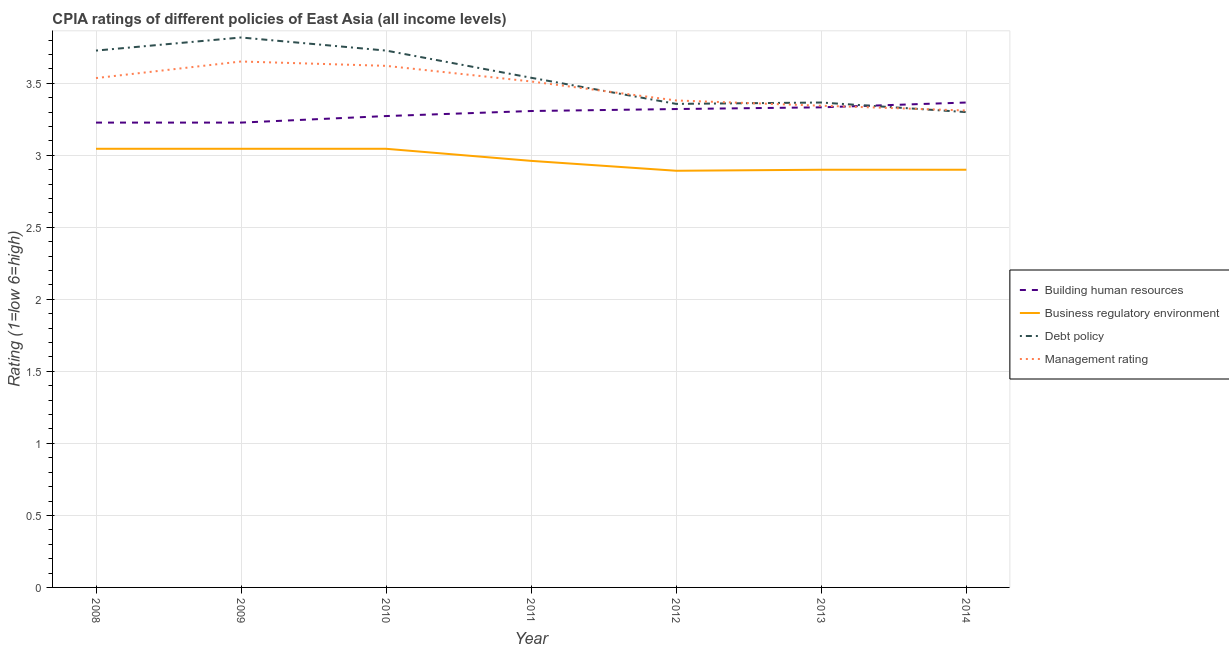What is the cpia rating of debt policy in 2011?
Provide a succinct answer. 3.54. Across all years, what is the maximum cpia rating of building human resources?
Provide a succinct answer. 3.37. What is the total cpia rating of building human resources in the graph?
Offer a terse response. 23.06. What is the difference between the cpia rating of debt policy in 2009 and that in 2011?
Offer a terse response. 0.28. What is the difference between the cpia rating of management in 2014 and the cpia rating of business regulatory environment in 2009?
Keep it short and to the point. 0.27. What is the average cpia rating of debt policy per year?
Provide a short and direct response. 3.55. In the year 2009, what is the difference between the cpia rating of management and cpia rating of debt policy?
Make the answer very short. -0.17. In how many years, is the cpia rating of management greater than 0.6?
Give a very brief answer. 7. What is the ratio of the cpia rating of business regulatory environment in 2010 to that in 2011?
Your answer should be compact. 1.03. Is the cpia rating of management in 2008 less than that in 2013?
Your answer should be compact. No. What is the difference between the highest and the second highest cpia rating of building human resources?
Your response must be concise. 0.03. What is the difference between the highest and the lowest cpia rating of building human resources?
Your response must be concise. 0.14. Is it the case that in every year, the sum of the cpia rating of management and cpia rating of business regulatory environment is greater than the sum of cpia rating of building human resources and cpia rating of debt policy?
Provide a short and direct response. No. Is it the case that in every year, the sum of the cpia rating of building human resources and cpia rating of business regulatory environment is greater than the cpia rating of debt policy?
Offer a very short reply. Yes. Does the graph contain grids?
Provide a succinct answer. Yes. Where does the legend appear in the graph?
Your answer should be compact. Center right. What is the title of the graph?
Give a very brief answer. CPIA ratings of different policies of East Asia (all income levels). Does "First 20% of population" appear as one of the legend labels in the graph?
Offer a terse response. No. What is the label or title of the X-axis?
Your response must be concise. Year. What is the label or title of the Y-axis?
Provide a succinct answer. Rating (1=low 6=high). What is the Rating (1=low 6=high) of Building human resources in 2008?
Make the answer very short. 3.23. What is the Rating (1=low 6=high) in Business regulatory environment in 2008?
Your answer should be very brief. 3.05. What is the Rating (1=low 6=high) of Debt policy in 2008?
Ensure brevity in your answer.  3.73. What is the Rating (1=low 6=high) in Management rating in 2008?
Your answer should be compact. 3.54. What is the Rating (1=low 6=high) of Building human resources in 2009?
Your answer should be very brief. 3.23. What is the Rating (1=low 6=high) of Business regulatory environment in 2009?
Offer a very short reply. 3.05. What is the Rating (1=low 6=high) of Debt policy in 2009?
Your answer should be very brief. 3.82. What is the Rating (1=low 6=high) of Management rating in 2009?
Give a very brief answer. 3.65. What is the Rating (1=low 6=high) in Building human resources in 2010?
Make the answer very short. 3.27. What is the Rating (1=low 6=high) in Business regulatory environment in 2010?
Give a very brief answer. 3.05. What is the Rating (1=low 6=high) of Debt policy in 2010?
Offer a terse response. 3.73. What is the Rating (1=low 6=high) in Management rating in 2010?
Provide a short and direct response. 3.62. What is the Rating (1=low 6=high) in Building human resources in 2011?
Offer a terse response. 3.31. What is the Rating (1=low 6=high) in Business regulatory environment in 2011?
Offer a very short reply. 2.96. What is the Rating (1=low 6=high) of Debt policy in 2011?
Offer a terse response. 3.54. What is the Rating (1=low 6=high) in Management rating in 2011?
Offer a terse response. 3.51. What is the Rating (1=low 6=high) of Building human resources in 2012?
Provide a succinct answer. 3.32. What is the Rating (1=low 6=high) of Business regulatory environment in 2012?
Keep it short and to the point. 2.89. What is the Rating (1=low 6=high) in Debt policy in 2012?
Offer a very short reply. 3.36. What is the Rating (1=low 6=high) in Management rating in 2012?
Your answer should be compact. 3.38. What is the Rating (1=low 6=high) in Building human resources in 2013?
Provide a short and direct response. 3.33. What is the Rating (1=low 6=high) in Business regulatory environment in 2013?
Provide a short and direct response. 2.9. What is the Rating (1=low 6=high) of Debt policy in 2013?
Provide a succinct answer. 3.37. What is the Rating (1=low 6=high) in Management rating in 2013?
Your response must be concise. 3.34. What is the Rating (1=low 6=high) of Building human resources in 2014?
Give a very brief answer. 3.37. What is the Rating (1=low 6=high) of Business regulatory environment in 2014?
Make the answer very short. 2.9. What is the Rating (1=low 6=high) of Management rating in 2014?
Ensure brevity in your answer.  3.31. Across all years, what is the maximum Rating (1=low 6=high) of Building human resources?
Your response must be concise. 3.37. Across all years, what is the maximum Rating (1=low 6=high) of Business regulatory environment?
Your answer should be very brief. 3.05. Across all years, what is the maximum Rating (1=low 6=high) in Debt policy?
Your answer should be compact. 3.82. Across all years, what is the maximum Rating (1=low 6=high) of Management rating?
Your answer should be compact. 3.65. Across all years, what is the minimum Rating (1=low 6=high) in Building human resources?
Your response must be concise. 3.23. Across all years, what is the minimum Rating (1=low 6=high) in Business regulatory environment?
Your response must be concise. 2.89. Across all years, what is the minimum Rating (1=low 6=high) of Debt policy?
Provide a short and direct response. 3.3. Across all years, what is the minimum Rating (1=low 6=high) in Management rating?
Provide a short and direct response. 3.31. What is the total Rating (1=low 6=high) of Building human resources in the graph?
Your response must be concise. 23.06. What is the total Rating (1=low 6=high) in Business regulatory environment in the graph?
Provide a succinct answer. 20.79. What is the total Rating (1=low 6=high) of Debt policy in the graph?
Provide a short and direct response. 24.84. What is the total Rating (1=low 6=high) in Management rating in the graph?
Keep it short and to the point. 24.36. What is the difference between the Rating (1=low 6=high) of Business regulatory environment in 2008 and that in 2009?
Your answer should be very brief. 0. What is the difference between the Rating (1=low 6=high) in Debt policy in 2008 and that in 2009?
Provide a succinct answer. -0.09. What is the difference between the Rating (1=low 6=high) in Management rating in 2008 and that in 2009?
Ensure brevity in your answer.  -0.12. What is the difference between the Rating (1=low 6=high) in Building human resources in 2008 and that in 2010?
Give a very brief answer. -0.05. What is the difference between the Rating (1=low 6=high) of Debt policy in 2008 and that in 2010?
Make the answer very short. 0. What is the difference between the Rating (1=low 6=high) in Management rating in 2008 and that in 2010?
Offer a very short reply. -0.08. What is the difference between the Rating (1=low 6=high) in Building human resources in 2008 and that in 2011?
Give a very brief answer. -0.08. What is the difference between the Rating (1=low 6=high) in Business regulatory environment in 2008 and that in 2011?
Offer a very short reply. 0.08. What is the difference between the Rating (1=low 6=high) in Debt policy in 2008 and that in 2011?
Give a very brief answer. 0.19. What is the difference between the Rating (1=low 6=high) of Management rating in 2008 and that in 2011?
Offer a very short reply. 0.02. What is the difference between the Rating (1=low 6=high) of Building human resources in 2008 and that in 2012?
Your response must be concise. -0.09. What is the difference between the Rating (1=low 6=high) of Business regulatory environment in 2008 and that in 2012?
Offer a very short reply. 0.15. What is the difference between the Rating (1=low 6=high) in Debt policy in 2008 and that in 2012?
Provide a short and direct response. 0.37. What is the difference between the Rating (1=low 6=high) in Management rating in 2008 and that in 2012?
Ensure brevity in your answer.  0.16. What is the difference between the Rating (1=low 6=high) of Building human resources in 2008 and that in 2013?
Your response must be concise. -0.11. What is the difference between the Rating (1=low 6=high) of Business regulatory environment in 2008 and that in 2013?
Ensure brevity in your answer.  0.15. What is the difference between the Rating (1=low 6=high) in Debt policy in 2008 and that in 2013?
Your response must be concise. 0.36. What is the difference between the Rating (1=low 6=high) of Management rating in 2008 and that in 2013?
Ensure brevity in your answer.  0.19. What is the difference between the Rating (1=low 6=high) in Building human resources in 2008 and that in 2014?
Ensure brevity in your answer.  -0.14. What is the difference between the Rating (1=low 6=high) of Business regulatory environment in 2008 and that in 2014?
Your answer should be very brief. 0.15. What is the difference between the Rating (1=low 6=high) of Debt policy in 2008 and that in 2014?
Make the answer very short. 0.43. What is the difference between the Rating (1=low 6=high) in Management rating in 2008 and that in 2014?
Your answer should be compact. 0.23. What is the difference between the Rating (1=low 6=high) of Building human resources in 2009 and that in 2010?
Your response must be concise. -0.05. What is the difference between the Rating (1=low 6=high) in Debt policy in 2009 and that in 2010?
Provide a succinct answer. 0.09. What is the difference between the Rating (1=low 6=high) of Management rating in 2009 and that in 2010?
Offer a terse response. 0.03. What is the difference between the Rating (1=low 6=high) in Building human resources in 2009 and that in 2011?
Keep it short and to the point. -0.08. What is the difference between the Rating (1=low 6=high) in Business regulatory environment in 2009 and that in 2011?
Offer a very short reply. 0.08. What is the difference between the Rating (1=low 6=high) in Debt policy in 2009 and that in 2011?
Make the answer very short. 0.28. What is the difference between the Rating (1=low 6=high) in Management rating in 2009 and that in 2011?
Provide a short and direct response. 0.14. What is the difference between the Rating (1=low 6=high) in Building human resources in 2009 and that in 2012?
Provide a succinct answer. -0.09. What is the difference between the Rating (1=low 6=high) of Business regulatory environment in 2009 and that in 2012?
Offer a terse response. 0.15. What is the difference between the Rating (1=low 6=high) in Debt policy in 2009 and that in 2012?
Offer a very short reply. 0.46. What is the difference between the Rating (1=low 6=high) in Management rating in 2009 and that in 2012?
Offer a terse response. 0.27. What is the difference between the Rating (1=low 6=high) of Building human resources in 2009 and that in 2013?
Make the answer very short. -0.11. What is the difference between the Rating (1=low 6=high) of Business regulatory environment in 2009 and that in 2013?
Ensure brevity in your answer.  0.15. What is the difference between the Rating (1=low 6=high) of Debt policy in 2009 and that in 2013?
Provide a short and direct response. 0.45. What is the difference between the Rating (1=low 6=high) of Management rating in 2009 and that in 2013?
Provide a succinct answer. 0.31. What is the difference between the Rating (1=low 6=high) in Building human resources in 2009 and that in 2014?
Offer a very short reply. -0.14. What is the difference between the Rating (1=low 6=high) of Business regulatory environment in 2009 and that in 2014?
Make the answer very short. 0.15. What is the difference between the Rating (1=low 6=high) of Debt policy in 2009 and that in 2014?
Your response must be concise. 0.52. What is the difference between the Rating (1=low 6=high) in Management rating in 2009 and that in 2014?
Give a very brief answer. 0.34. What is the difference between the Rating (1=low 6=high) in Building human resources in 2010 and that in 2011?
Keep it short and to the point. -0.04. What is the difference between the Rating (1=low 6=high) in Business regulatory environment in 2010 and that in 2011?
Your answer should be very brief. 0.08. What is the difference between the Rating (1=low 6=high) in Debt policy in 2010 and that in 2011?
Keep it short and to the point. 0.19. What is the difference between the Rating (1=low 6=high) in Management rating in 2010 and that in 2011?
Offer a very short reply. 0.11. What is the difference between the Rating (1=low 6=high) of Building human resources in 2010 and that in 2012?
Ensure brevity in your answer.  -0.05. What is the difference between the Rating (1=low 6=high) of Business regulatory environment in 2010 and that in 2012?
Provide a succinct answer. 0.15. What is the difference between the Rating (1=low 6=high) of Debt policy in 2010 and that in 2012?
Ensure brevity in your answer.  0.37. What is the difference between the Rating (1=low 6=high) in Management rating in 2010 and that in 2012?
Make the answer very short. 0.24. What is the difference between the Rating (1=low 6=high) in Building human resources in 2010 and that in 2013?
Make the answer very short. -0.06. What is the difference between the Rating (1=low 6=high) of Business regulatory environment in 2010 and that in 2013?
Your answer should be compact. 0.15. What is the difference between the Rating (1=low 6=high) of Debt policy in 2010 and that in 2013?
Provide a short and direct response. 0.36. What is the difference between the Rating (1=low 6=high) in Management rating in 2010 and that in 2013?
Provide a short and direct response. 0.28. What is the difference between the Rating (1=low 6=high) in Building human resources in 2010 and that in 2014?
Give a very brief answer. -0.09. What is the difference between the Rating (1=low 6=high) of Business regulatory environment in 2010 and that in 2014?
Provide a succinct answer. 0.15. What is the difference between the Rating (1=low 6=high) in Debt policy in 2010 and that in 2014?
Offer a very short reply. 0.43. What is the difference between the Rating (1=low 6=high) of Management rating in 2010 and that in 2014?
Your answer should be compact. 0.31. What is the difference between the Rating (1=low 6=high) of Building human resources in 2011 and that in 2012?
Keep it short and to the point. -0.01. What is the difference between the Rating (1=low 6=high) of Business regulatory environment in 2011 and that in 2012?
Give a very brief answer. 0.07. What is the difference between the Rating (1=low 6=high) in Debt policy in 2011 and that in 2012?
Give a very brief answer. 0.18. What is the difference between the Rating (1=low 6=high) in Management rating in 2011 and that in 2012?
Provide a succinct answer. 0.13. What is the difference between the Rating (1=low 6=high) in Building human resources in 2011 and that in 2013?
Give a very brief answer. -0.03. What is the difference between the Rating (1=low 6=high) in Business regulatory environment in 2011 and that in 2013?
Make the answer very short. 0.06. What is the difference between the Rating (1=low 6=high) of Debt policy in 2011 and that in 2013?
Make the answer very short. 0.17. What is the difference between the Rating (1=low 6=high) in Management rating in 2011 and that in 2013?
Your answer should be compact. 0.17. What is the difference between the Rating (1=low 6=high) of Building human resources in 2011 and that in 2014?
Keep it short and to the point. -0.06. What is the difference between the Rating (1=low 6=high) in Business regulatory environment in 2011 and that in 2014?
Provide a short and direct response. 0.06. What is the difference between the Rating (1=low 6=high) of Debt policy in 2011 and that in 2014?
Your response must be concise. 0.24. What is the difference between the Rating (1=low 6=high) of Management rating in 2011 and that in 2014?
Your answer should be compact. 0.2. What is the difference between the Rating (1=low 6=high) of Building human resources in 2012 and that in 2013?
Give a very brief answer. -0.01. What is the difference between the Rating (1=low 6=high) of Business regulatory environment in 2012 and that in 2013?
Make the answer very short. -0.01. What is the difference between the Rating (1=low 6=high) of Debt policy in 2012 and that in 2013?
Offer a terse response. -0.01. What is the difference between the Rating (1=low 6=high) in Management rating in 2012 and that in 2013?
Make the answer very short. 0.04. What is the difference between the Rating (1=low 6=high) in Building human resources in 2012 and that in 2014?
Provide a succinct answer. -0.05. What is the difference between the Rating (1=low 6=high) of Business regulatory environment in 2012 and that in 2014?
Your response must be concise. -0.01. What is the difference between the Rating (1=low 6=high) in Debt policy in 2012 and that in 2014?
Provide a succinct answer. 0.06. What is the difference between the Rating (1=low 6=high) of Management rating in 2012 and that in 2014?
Offer a terse response. 0.07. What is the difference between the Rating (1=low 6=high) of Building human resources in 2013 and that in 2014?
Your answer should be very brief. -0.03. What is the difference between the Rating (1=low 6=high) of Debt policy in 2013 and that in 2014?
Your answer should be compact. 0.07. What is the difference between the Rating (1=low 6=high) of Building human resources in 2008 and the Rating (1=low 6=high) of Business regulatory environment in 2009?
Provide a short and direct response. 0.18. What is the difference between the Rating (1=low 6=high) in Building human resources in 2008 and the Rating (1=low 6=high) in Debt policy in 2009?
Your answer should be very brief. -0.59. What is the difference between the Rating (1=low 6=high) in Building human resources in 2008 and the Rating (1=low 6=high) in Management rating in 2009?
Your answer should be compact. -0.42. What is the difference between the Rating (1=low 6=high) of Business regulatory environment in 2008 and the Rating (1=low 6=high) of Debt policy in 2009?
Your answer should be very brief. -0.77. What is the difference between the Rating (1=low 6=high) of Business regulatory environment in 2008 and the Rating (1=low 6=high) of Management rating in 2009?
Your answer should be compact. -0.61. What is the difference between the Rating (1=low 6=high) of Debt policy in 2008 and the Rating (1=low 6=high) of Management rating in 2009?
Your response must be concise. 0.08. What is the difference between the Rating (1=low 6=high) of Building human resources in 2008 and the Rating (1=low 6=high) of Business regulatory environment in 2010?
Your response must be concise. 0.18. What is the difference between the Rating (1=low 6=high) in Building human resources in 2008 and the Rating (1=low 6=high) in Debt policy in 2010?
Make the answer very short. -0.5. What is the difference between the Rating (1=low 6=high) of Building human resources in 2008 and the Rating (1=low 6=high) of Management rating in 2010?
Your response must be concise. -0.39. What is the difference between the Rating (1=low 6=high) of Business regulatory environment in 2008 and the Rating (1=low 6=high) of Debt policy in 2010?
Your answer should be very brief. -0.68. What is the difference between the Rating (1=low 6=high) of Business regulatory environment in 2008 and the Rating (1=low 6=high) of Management rating in 2010?
Your answer should be very brief. -0.58. What is the difference between the Rating (1=low 6=high) of Debt policy in 2008 and the Rating (1=low 6=high) of Management rating in 2010?
Offer a very short reply. 0.11. What is the difference between the Rating (1=low 6=high) of Building human resources in 2008 and the Rating (1=low 6=high) of Business regulatory environment in 2011?
Ensure brevity in your answer.  0.27. What is the difference between the Rating (1=low 6=high) in Building human resources in 2008 and the Rating (1=low 6=high) in Debt policy in 2011?
Your answer should be compact. -0.31. What is the difference between the Rating (1=low 6=high) of Building human resources in 2008 and the Rating (1=low 6=high) of Management rating in 2011?
Make the answer very short. -0.29. What is the difference between the Rating (1=low 6=high) of Business regulatory environment in 2008 and the Rating (1=low 6=high) of Debt policy in 2011?
Keep it short and to the point. -0.49. What is the difference between the Rating (1=low 6=high) in Business regulatory environment in 2008 and the Rating (1=low 6=high) in Management rating in 2011?
Give a very brief answer. -0.47. What is the difference between the Rating (1=low 6=high) of Debt policy in 2008 and the Rating (1=low 6=high) of Management rating in 2011?
Your response must be concise. 0.21. What is the difference between the Rating (1=low 6=high) in Building human resources in 2008 and the Rating (1=low 6=high) in Business regulatory environment in 2012?
Provide a short and direct response. 0.33. What is the difference between the Rating (1=low 6=high) in Building human resources in 2008 and the Rating (1=low 6=high) in Debt policy in 2012?
Offer a terse response. -0.13. What is the difference between the Rating (1=low 6=high) of Building human resources in 2008 and the Rating (1=low 6=high) of Management rating in 2012?
Provide a succinct answer. -0.15. What is the difference between the Rating (1=low 6=high) in Business regulatory environment in 2008 and the Rating (1=low 6=high) in Debt policy in 2012?
Offer a very short reply. -0.31. What is the difference between the Rating (1=low 6=high) in Business regulatory environment in 2008 and the Rating (1=low 6=high) in Management rating in 2012?
Your answer should be very brief. -0.34. What is the difference between the Rating (1=low 6=high) of Debt policy in 2008 and the Rating (1=low 6=high) of Management rating in 2012?
Your response must be concise. 0.35. What is the difference between the Rating (1=low 6=high) in Building human resources in 2008 and the Rating (1=low 6=high) in Business regulatory environment in 2013?
Provide a short and direct response. 0.33. What is the difference between the Rating (1=low 6=high) in Building human resources in 2008 and the Rating (1=low 6=high) in Debt policy in 2013?
Make the answer very short. -0.14. What is the difference between the Rating (1=low 6=high) in Building human resources in 2008 and the Rating (1=low 6=high) in Management rating in 2013?
Offer a terse response. -0.12. What is the difference between the Rating (1=low 6=high) in Business regulatory environment in 2008 and the Rating (1=low 6=high) in Debt policy in 2013?
Your answer should be very brief. -0.32. What is the difference between the Rating (1=low 6=high) of Business regulatory environment in 2008 and the Rating (1=low 6=high) of Management rating in 2013?
Your response must be concise. -0.3. What is the difference between the Rating (1=low 6=high) in Debt policy in 2008 and the Rating (1=low 6=high) in Management rating in 2013?
Provide a short and direct response. 0.38. What is the difference between the Rating (1=low 6=high) in Building human resources in 2008 and the Rating (1=low 6=high) in Business regulatory environment in 2014?
Provide a short and direct response. 0.33. What is the difference between the Rating (1=low 6=high) of Building human resources in 2008 and the Rating (1=low 6=high) of Debt policy in 2014?
Your answer should be very brief. -0.07. What is the difference between the Rating (1=low 6=high) in Building human resources in 2008 and the Rating (1=low 6=high) in Management rating in 2014?
Offer a terse response. -0.08. What is the difference between the Rating (1=low 6=high) of Business regulatory environment in 2008 and the Rating (1=low 6=high) of Debt policy in 2014?
Your answer should be very brief. -0.25. What is the difference between the Rating (1=low 6=high) of Business regulatory environment in 2008 and the Rating (1=low 6=high) of Management rating in 2014?
Your answer should be very brief. -0.27. What is the difference between the Rating (1=low 6=high) in Debt policy in 2008 and the Rating (1=low 6=high) in Management rating in 2014?
Your answer should be compact. 0.42. What is the difference between the Rating (1=low 6=high) in Building human resources in 2009 and the Rating (1=low 6=high) in Business regulatory environment in 2010?
Provide a short and direct response. 0.18. What is the difference between the Rating (1=low 6=high) of Building human resources in 2009 and the Rating (1=low 6=high) of Debt policy in 2010?
Keep it short and to the point. -0.5. What is the difference between the Rating (1=low 6=high) in Building human resources in 2009 and the Rating (1=low 6=high) in Management rating in 2010?
Offer a terse response. -0.39. What is the difference between the Rating (1=low 6=high) of Business regulatory environment in 2009 and the Rating (1=low 6=high) of Debt policy in 2010?
Your response must be concise. -0.68. What is the difference between the Rating (1=low 6=high) in Business regulatory environment in 2009 and the Rating (1=low 6=high) in Management rating in 2010?
Ensure brevity in your answer.  -0.58. What is the difference between the Rating (1=low 6=high) of Debt policy in 2009 and the Rating (1=low 6=high) of Management rating in 2010?
Keep it short and to the point. 0.2. What is the difference between the Rating (1=low 6=high) of Building human resources in 2009 and the Rating (1=low 6=high) of Business regulatory environment in 2011?
Your answer should be compact. 0.27. What is the difference between the Rating (1=low 6=high) of Building human resources in 2009 and the Rating (1=low 6=high) of Debt policy in 2011?
Ensure brevity in your answer.  -0.31. What is the difference between the Rating (1=low 6=high) in Building human resources in 2009 and the Rating (1=low 6=high) in Management rating in 2011?
Ensure brevity in your answer.  -0.29. What is the difference between the Rating (1=low 6=high) in Business regulatory environment in 2009 and the Rating (1=low 6=high) in Debt policy in 2011?
Your response must be concise. -0.49. What is the difference between the Rating (1=low 6=high) of Business regulatory environment in 2009 and the Rating (1=low 6=high) of Management rating in 2011?
Provide a short and direct response. -0.47. What is the difference between the Rating (1=low 6=high) in Debt policy in 2009 and the Rating (1=low 6=high) in Management rating in 2011?
Make the answer very short. 0.31. What is the difference between the Rating (1=low 6=high) in Building human resources in 2009 and the Rating (1=low 6=high) in Business regulatory environment in 2012?
Keep it short and to the point. 0.33. What is the difference between the Rating (1=low 6=high) in Building human resources in 2009 and the Rating (1=low 6=high) in Debt policy in 2012?
Offer a very short reply. -0.13. What is the difference between the Rating (1=low 6=high) in Building human resources in 2009 and the Rating (1=low 6=high) in Management rating in 2012?
Provide a short and direct response. -0.15. What is the difference between the Rating (1=low 6=high) in Business regulatory environment in 2009 and the Rating (1=low 6=high) in Debt policy in 2012?
Provide a short and direct response. -0.31. What is the difference between the Rating (1=low 6=high) of Business regulatory environment in 2009 and the Rating (1=low 6=high) of Management rating in 2012?
Offer a terse response. -0.34. What is the difference between the Rating (1=low 6=high) of Debt policy in 2009 and the Rating (1=low 6=high) of Management rating in 2012?
Give a very brief answer. 0.44. What is the difference between the Rating (1=low 6=high) in Building human resources in 2009 and the Rating (1=low 6=high) in Business regulatory environment in 2013?
Ensure brevity in your answer.  0.33. What is the difference between the Rating (1=low 6=high) of Building human resources in 2009 and the Rating (1=low 6=high) of Debt policy in 2013?
Provide a short and direct response. -0.14. What is the difference between the Rating (1=low 6=high) of Building human resources in 2009 and the Rating (1=low 6=high) of Management rating in 2013?
Your answer should be compact. -0.12. What is the difference between the Rating (1=low 6=high) in Business regulatory environment in 2009 and the Rating (1=low 6=high) in Debt policy in 2013?
Your answer should be compact. -0.32. What is the difference between the Rating (1=low 6=high) of Business regulatory environment in 2009 and the Rating (1=low 6=high) of Management rating in 2013?
Provide a short and direct response. -0.3. What is the difference between the Rating (1=low 6=high) in Debt policy in 2009 and the Rating (1=low 6=high) in Management rating in 2013?
Keep it short and to the point. 0.47. What is the difference between the Rating (1=low 6=high) of Building human resources in 2009 and the Rating (1=low 6=high) of Business regulatory environment in 2014?
Make the answer very short. 0.33. What is the difference between the Rating (1=low 6=high) of Building human resources in 2009 and the Rating (1=low 6=high) of Debt policy in 2014?
Give a very brief answer. -0.07. What is the difference between the Rating (1=low 6=high) in Building human resources in 2009 and the Rating (1=low 6=high) in Management rating in 2014?
Your answer should be very brief. -0.08. What is the difference between the Rating (1=low 6=high) in Business regulatory environment in 2009 and the Rating (1=low 6=high) in Debt policy in 2014?
Your answer should be compact. -0.25. What is the difference between the Rating (1=low 6=high) in Business regulatory environment in 2009 and the Rating (1=low 6=high) in Management rating in 2014?
Keep it short and to the point. -0.27. What is the difference between the Rating (1=low 6=high) in Debt policy in 2009 and the Rating (1=low 6=high) in Management rating in 2014?
Offer a terse response. 0.51. What is the difference between the Rating (1=low 6=high) of Building human resources in 2010 and the Rating (1=low 6=high) of Business regulatory environment in 2011?
Keep it short and to the point. 0.31. What is the difference between the Rating (1=low 6=high) of Building human resources in 2010 and the Rating (1=low 6=high) of Debt policy in 2011?
Your answer should be compact. -0.27. What is the difference between the Rating (1=low 6=high) in Building human resources in 2010 and the Rating (1=low 6=high) in Management rating in 2011?
Make the answer very short. -0.24. What is the difference between the Rating (1=low 6=high) of Business regulatory environment in 2010 and the Rating (1=low 6=high) of Debt policy in 2011?
Keep it short and to the point. -0.49. What is the difference between the Rating (1=low 6=high) of Business regulatory environment in 2010 and the Rating (1=low 6=high) of Management rating in 2011?
Provide a succinct answer. -0.47. What is the difference between the Rating (1=low 6=high) in Debt policy in 2010 and the Rating (1=low 6=high) in Management rating in 2011?
Offer a terse response. 0.21. What is the difference between the Rating (1=low 6=high) of Building human resources in 2010 and the Rating (1=low 6=high) of Business regulatory environment in 2012?
Provide a short and direct response. 0.38. What is the difference between the Rating (1=low 6=high) in Building human resources in 2010 and the Rating (1=low 6=high) in Debt policy in 2012?
Your response must be concise. -0.08. What is the difference between the Rating (1=low 6=high) of Building human resources in 2010 and the Rating (1=low 6=high) of Management rating in 2012?
Offer a terse response. -0.11. What is the difference between the Rating (1=low 6=high) of Business regulatory environment in 2010 and the Rating (1=low 6=high) of Debt policy in 2012?
Provide a short and direct response. -0.31. What is the difference between the Rating (1=low 6=high) of Business regulatory environment in 2010 and the Rating (1=low 6=high) of Management rating in 2012?
Offer a terse response. -0.34. What is the difference between the Rating (1=low 6=high) in Debt policy in 2010 and the Rating (1=low 6=high) in Management rating in 2012?
Your response must be concise. 0.35. What is the difference between the Rating (1=low 6=high) of Building human resources in 2010 and the Rating (1=low 6=high) of Business regulatory environment in 2013?
Your response must be concise. 0.37. What is the difference between the Rating (1=low 6=high) of Building human resources in 2010 and the Rating (1=low 6=high) of Debt policy in 2013?
Ensure brevity in your answer.  -0.09. What is the difference between the Rating (1=low 6=high) of Building human resources in 2010 and the Rating (1=low 6=high) of Management rating in 2013?
Your response must be concise. -0.07. What is the difference between the Rating (1=low 6=high) in Business regulatory environment in 2010 and the Rating (1=low 6=high) in Debt policy in 2013?
Your answer should be compact. -0.32. What is the difference between the Rating (1=low 6=high) in Business regulatory environment in 2010 and the Rating (1=low 6=high) in Management rating in 2013?
Offer a terse response. -0.3. What is the difference between the Rating (1=low 6=high) in Debt policy in 2010 and the Rating (1=low 6=high) in Management rating in 2013?
Keep it short and to the point. 0.38. What is the difference between the Rating (1=low 6=high) in Building human resources in 2010 and the Rating (1=low 6=high) in Business regulatory environment in 2014?
Provide a short and direct response. 0.37. What is the difference between the Rating (1=low 6=high) in Building human resources in 2010 and the Rating (1=low 6=high) in Debt policy in 2014?
Your answer should be compact. -0.03. What is the difference between the Rating (1=low 6=high) of Building human resources in 2010 and the Rating (1=low 6=high) of Management rating in 2014?
Your answer should be very brief. -0.04. What is the difference between the Rating (1=low 6=high) of Business regulatory environment in 2010 and the Rating (1=low 6=high) of Debt policy in 2014?
Your answer should be very brief. -0.25. What is the difference between the Rating (1=low 6=high) in Business regulatory environment in 2010 and the Rating (1=low 6=high) in Management rating in 2014?
Your answer should be very brief. -0.27. What is the difference between the Rating (1=low 6=high) of Debt policy in 2010 and the Rating (1=low 6=high) of Management rating in 2014?
Your answer should be very brief. 0.42. What is the difference between the Rating (1=low 6=high) of Building human resources in 2011 and the Rating (1=low 6=high) of Business regulatory environment in 2012?
Offer a terse response. 0.41. What is the difference between the Rating (1=low 6=high) of Building human resources in 2011 and the Rating (1=low 6=high) of Debt policy in 2012?
Ensure brevity in your answer.  -0.05. What is the difference between the Rating (1=low 6=high) in Building human resources in 2011 and the Rating (1=low 6=high) in Management rating in 2012?
Your answer should be very brief. -0.07. What is the difference between the Rating (1=low 6=high) in Business regulatory environment in 2011 and the Rating (1=low 6=high) in Debt policy in 2012?
Give a very brief answer. -0.4. What is the difference between the Rating (1=low 6=high) of Business regulatory environment in 2011 and the Rating (1=low 6=high) of Management rating in 2012?
Offer a terse response. -0.42. What is the difference between the Rating (1=low 6=high) of Debt policy in 2011 and the Rating (1=low 6=high) of Management rating in 2012?
Ensure brevity in your answer.  0.16. What is the difference between the Rating (1=low 6=high) in Building human resources in 2011 and the Rating (1=low 6=high) in Business regulatory environment in 2013?
Give a very brief answer. 0.41. What is the difference between the Rating (1=low 6=high) in Building human resources in 2011 and the Rating (1=low 6=high) in Debt policy in 2013?
Provide a succinct answer. -0.06. What is the difference between the Rating (1=low 6=high) of Building human resources in 2011 and the Rating (1=low 6=high) of Management rating in 2013?
Ensure brevity in your answer.  -0.04. What is the difference between the Rating (1=low 6=high) of Business regulatory environment in 2011 and the Rating (1=low 6=high) of Debt policy in 2013?
Offer a very short reply. -0.41. What is the difference between the Rating (1=low 6=high) of Business regulatory environment in 2011 and the Rating (1=low 6=high) of Management rating in 2013?
Keep it short and to the point. -0.38. What is the difference between the Rating (1=low 6=high) of Debt policy in 2011 and the Rating (1=low 6=high) of Management rating in 2013?
Ensure brevity in your answer.  0.19. What is the difference between the Rating (1=low 6=high) of Building human resources in 2011 and the Rating (1=low 6=high) of Business regulatory environment in 2014?
Make the answer very short. 0.41. What is the difference between the Rating (1=low 6=high) in Building human resources in 2011 and the Rating (1=low 6=high) in Debt policy in 2014?
Provide a succinct answer. 0.01. What is the difference between the Rating (1=low 6=high) of Building human resources in 2011 and the Rating (1=low 6=high) of Management rating in 2014?
Offer a very short reply. -0. What is the difference between the Rating (1=low 6=high) of Business regulatory environment in 2011 and the Rating (1=low 6=high) of Debt policy in 2014?
Your response must be concise. -0.34. What is the difference between the Rating (1=low 6=high) in Business regulatory environment in 2011 and the Rating (1=low 6=high) in Management rating in 2014?
Keep it short and to the point. -0.35. What is the difference between the Rating (1=low 6=high) of Debt policy in 2011 and the Rating (1=low 6=high) of Management rating in 2014?
Offer a terse response. 0.23. What is the difference between the Rating (1=low 6=high) of Building human resources in 2012 and the Rating (1=low 6=high) of Business regulatory environment in 2013?
Give a very brief answer. 0.42. What is the difference between the Rating (1=low 6=high) in Building human resources in 2012 and the Rating (1=low 6=high) in Debt policy in 2013?
Offer a terse response. -0.05. What is the difference between the Rating (1=low 6=high) of Building human resources in 2012 and the Rating (1=low 6=high) of Management rating in 2013?
Ensure brevity in your answer.  -0.02. What is the difference between the Rating (1=low 6=high) of Business regulatory environment in 2012 and the Rating (1=low 6=high) of Debt policy in 2013?
Offer a very short reply. -0.47. What is the difference between the Rating (1=low 6=high) of Business regulatory environment in 2012 and the Rating (1=low 6=high) of Management rating in 2013?
Your response must be concise. -0.45. What is the difference between the Rating (1=low 6=high) of Debt policy in 2012 and the Rating (1=low 6=high) of Management rating in 2013?
Keep it short and to the point. 0.01. What is the difference between the Rating (1=low 6=high) in Building human resources in 2012 and the Rating (1=low 6=high) in Business regulatory environment in 2014?
Provide a succinct answer. 0.42. What is the difference between the Rating (1=low 6=high) of Building human resources in 2012 and the Rating (1=low 6=high) of Debt policy in 2014?
Your answer should be compact. 0.02. What is the difference between the Rating (1=low 6=high) of Building human resources in 2012 and the Rating (1=low 6=high) of Management rating in 2014?
Keep it short and to the point. 0.01. What is the difference between the Rating (1=low 6=high) in Business regulatory environment in 2012 and the Rating (1=low 6=high) in Debt policy in 2014?
Your answer should be compact. -0.41. What is the difference between the Rating (1=low 6=high) of Business regulatory environment in 2012 and the Rating (1=low 6=high) of Management rating in 2014?
Provide a short and direct response. -0.42. What is the difference between the Rating (1=low 6=high) in Debt policy in 2012 and the Rating (1=low 6=high) in Management rating in 2014?
Offer a very short reply. 0.05. What is the difference between the Rating (1=low 6=high) in Building human resources in 2013 and the Rating (1=low 6=high) in Business regulatory environment in 2014?
Provide a short and direct response. 0.43. What is the difference between the Rating (1=low 6=high) in Building human resources in 2013 and the Rating (1=low 6=high) in Management rating in 2014?
Offer a very short reply. 0.02. What is the difference between the Rating (1=low 6=high) of Business regulatory environment in 2013 and the Rating (1=low 6=high) of Debt policy in 2014?
Your answer should be compact. -0.4. What is the difference between the Rating (1=low 6=high) in Business regulatory environment in 2013 and the Rating (1=low 6=high) in Management rating in 2014?
Make the answer very short. -0.41. What is the difference between the Rating (1=low 6=high) in Debt policy in 2013 and the Rating (1=low 6=high) in Management rating in 2014?
Give a very brief answer. 0.06. What is the average Rating (1=low 6=high) of Building human resources per year?
Give a very brief answer. 3.29. What is the average Rating (1=low 6=high) in Business regulatory environment per year?
Make the answer very short. 2.97. What is the average Rating (1=low 6=high) of Debt policy per year?
Offer a very short reply. 3.55. What is the average Rating (1=low 6=high) in Management rating per year?
Make the answer very short. 3.48. In the year 2008, what is the difference between the Rating (1=low 6=high) of Building human resources and Rating (1=low 6=high) of Business regulatory environment?
Ensure brevity in your answer.  0.18. In the year 2008, what is the difference between the Rating (1=low 6=high) of Building human resources and Rating (1=low 6=high) of Debt policy?
Your response must be concise. -0.5. In the year 2008, what is the difference between the Rating (1=low 6=high) in Building human resources and Rating (1=low 6=high) in Management rating?
Provide a succinct answer. -0.31. In the year 2008, what is the difference between the Rating (1=low 6=high) of Business regulatory environment and Rating (1=low 6=high) of Debt policy?
Make the answer very short. -0.68. In the year 2008, what is the difference between the Rating (1=low 6=high) of Business regulatory environment and Rating (1=low 6=high) of Management rating?
Your response must be concise. -0.49. In the year 2008, what is the difference between the Rating (1=low 6=high) of Debt policy and Rating (1=low 6=high) of Management rating?
Provide a succinct answer. 0.19. In the year 2009, what is the difference between the Rating (1=low 6=high) in Building human resources and Rating (1=low 6=high) in Business regulatory environment?
Keep it short and to the point. 0.18. In the year 2009, what is the difference between the Rating (1=low 6=high) of Building human resources and Rating (1=low 6=high) of Debt policy?
Make the answer very short. -0.59. In the year 2009, what is the difference between the Rating (1=low 6=high) of Building human resources and Rating (1=low 6=high) of Management rating?
Provide a short and direct response. -0.42. In the year 2009, what is the difference between the Rating (1=low 6=high) in Business regulatory environment and Rating (1=low 6=high) in Debt policy?
Offer a terse response. -0.77. In the year 2009, what is the difference between the Rating (1=low 6=high) of Business regulatory environment and Rating (1=low 6=high) of Management rating?
Your answer should be very brief. -0.61. In the year 2010, what is the difference between the Rating (1=low 6=high) in Building human resources and Rating (1=low 6=high) in Business regulatory environment?
Provide a succinct answer. 0.23. In the year 2010, what is the difference between the Rating (1=low 6=high) of Building human resources and Rating (1=low 6=high) of Debt policy?
Provide a short and direct response. -0.45. In the year 2010, what is the difference between the Rating (1=low 6=high) of Building human resources and Rating (1=low 6=high) of Management rating?
Provide a short and direct response. -0.35. In the year 2010, what is the difference between the Rating (1=low 6=high) of Business regulatory environment and Rating (1=low 6=high) of Debt policy?
Your answer should be very brief. -0.68. In the year 2010, what is the difference between the Rating (1=low 6=high) in Business regulatory environment and Rating (1=low 6=high) in Management rating?
Your answer should be very brief. -0.58. In the year 2010, what is the difference between the Rating (1=low 6=high) in Debt policy and Rating (1=low 6=high) in Management rating?
Offer a very short reply. 0.11. In the year 2011, what is the difference between the Rating (1=low 6=high) in Building human resources and Rating (1=low 6=high) in Business regulatory environment?
Ensure brevity in your answer.  0.35. In the year 2011, what is the difference between the Rating (1=low 6=high) of Building human resources and Rating (1=low 6=high) of Debt policy?
Your answer should be compact. -0.23. In the year 2011, what is the difference between the Rating (1=low 6=high) in Building human resources and Rating (1=low 6=high) in Management rating?
Your answer should be very brief. -0.21. In the year 2011, what is the difference between the Rating (1=low 6=high) of Business regulatory environment and Rating (1=low 6=high) of Debt policy?
Give a very brief answer. -0.58. In the year 2011, what is the difference between the Rating (1=low 6=high) in Business regulatory environment and Rating (1=low 6=high) in Management rating?
Offer a terse response. -0.55. In the year 2011, what is the difference between the Rating (1=low 6=high) of Debt policy and Rating (1=low 6=high) of Management rating?
Ensure brevity in your answer.  0.03. In the year 2012, what is the difference between the Rating (1=low 6=high) of Building human resources and Rating (1=low 6=high) of Business regulatory environment?
Provide a succinct answer. 0.43. In the year 2012, what is the difference between the Rating (1=low 6=high) in Building human resources and Rating (1=low 6=high) in Debt policy?
Offer a very short reply. -0.04. In the year 2012, what is the difference between the Rating (1=low 6=high) in Building human resources and Rating (1=low 6=high) in Management rating?
Keep it short and to the point. -0.06. In the year 2012, what is the difference between the Rating (1=low 6=high) in Business regulatory environment and Rating (1=low 6=high) in Debt policy?
Your answer should be very brief. -0.46. In the year 2012, what is the difference between the Rating (1=low 6=high) in Business regulatory environment and Rating (1=low 6=high) in Management rating?
Your response must be concise. -0.49. In the year 2012, what is the difference between the Rating (1=low 6=high) in Debt policy and Rating (1=low 6=high) in Management rating?
Your answer should be compact. -0.02. In the year 2013, what is the difference between the Rating (1=low 6=high) of Building human resources and Rating (1=low 6=high) of Business regulatory environment?
Your answer should be very brief. 0.43. In the year 2013, what is the difference between the Rating (1=low 6=high) in Building human resources and Rating (1=low 6=high) in Debt policy?
Provide a short and direct response. -0.03. In the year 2013, what is the difference between the Rating (1=low 6=high) of Building human resources and Rating (1=low 6=high) of Management rating?
Your response must be concise. -0.01. In the year 2013, what is the difference between the Rating (1=low 6=high) in Business regulatory environment and Rating (1=low 6=high) in Debt policy?
Offer a terse response. -0.47. In the year 2013, what is the difference between the Rating (1=low 6=high) in Business regulatory environment and Rating (1=low 6=high) in Management rating?
Provide a short and direct response. -0.44. In the year 2013, what is the difference between the Rating (1=low 6=high) of Debt policy and Rating (1=low 6=high) of Management rating?
Your answer should be compact. 0.02. In the year 2014, what is the difference between the Rating (1=low 6=high) of Building human resources and Rating (1=low 6=high) of Business regulatory environment?
Your response must be concise. 0.47. In the year 2014, what is the difference between the Rating (1=low 6=high) of Building human resources and Rating (1=low 6=high) of Debt policy?
Offer a very short reply. 0.07. In the year 2014, what is the difference between the Rating (1=low 6=high) in Building human resources and Rating (1=low 6=high) in Management rating?
Provide a short and direct response. 0.06. In the year 2014, what is the difference between the Rating (1=low 6=high) of Business regulatory environment and Rating (1=low 6=high) of Debt policy?
Ensure brevity in your answer.  -0.4. In the year 2014, what is the difference between the Rating (1=low 6=high) in Business regulatory environment and Rating (1=low 6=high) in Management rating?
Ensure brevity in your answer.  -0.41. In the year 2014, what is the difference between the Rating (1=low 6=high) in Debt policy and Rating (1=low 6=high) in Management rating?
Provide a succinct answer. -0.01. What is the ratio of the Rating (1=low 6=high) in Debt policy in 2008 to that in 2009?
Provide a short and direct response. 0.98. What is the ratio of the Rating (1=low 6=high) in Management rating in 2008 to that in 2009?
Your answer should be very brief. 0.97. What is the ratio of the Rating (1=low 6=high) of Building human resources in 2008 to that in 2010?
Provide a succinct answer. 0.99. What is the ratio of the Rating (1=low 6=high) of Debt policy in 2008 to that in 2010?
Offer a very short reply. 1. What is the ratio of the Rating (1=low 6=high) of Management rating in 2008 to that in 2010?
Your answer should be compact. 0.98. What is the ratio of the Rating (1=low 6=high) in Building human resources in 2008 to that in 2011?
Provide a succinct answer. 0.98. What is the ratio of the Rating (1=low 6=high) in Business regulatory environment in 2008 to that in 2011?
Provide a succinct answer. 1.03. What is the ratio of the Rating (1=low 6=high) of Debt policy in 2008 to that in 2011?
Keep it short and to the point. 1.05. What is the ratio of the Rating (1=low 6=high) of Management rating in 2008 to that in 2011?
Your answer should be very brief. 1.01. What is the ratio of the Rating (1=low 6=high) of Building human resources in 2008 to that in 2012?
Your answer should be very brief. 0.97. What is the ratio of the Rating (1=low 6=high) in Business regulatory environment in 2008 to that in 2012?
Your answer should be compact. 1.05. What is the ratio of the Rating (1=low 6=high) in Debt policy in 2008 to that in 2012?
Your answer should be compact. 1.11. What is the ratio of the Rating (1=low 6=high) in Management rating in 2008 to that in 2012?
Ensure brevity in your answer.  1.05. What is the ratio of the Rating (1=low 6=high) in Building human resources in 2008 to that in 2013?
Your response must be concise. 0.97. What is the ratio of the Rating (1=low 6=high) of Business regulatory environment in 2008 to that in 2013?
Make the answer very short. 1.05. What is the ratio of the Rating (1=low 6=high) in Debt policy in 2008 to that in 2013?
Offer a terse response. 1.11. What is the ratio of the Rating (1=low 6=high) of Management rating in 2008 to that in 2013?
Offer a very short reply. 1.06. What is the ratio of the Rating (1=low 6=high) of Building human resources in 2008 to that in 2014?
Offer a very short reply. 0.96. What is the ratio of the Rating (1=low 6=high) in Business regulatory environment in 2008 to that in 2014?
Your answer should be compact. 1.05. What is the ratio of the Rating (1=low 6=high) of Debt policy in 2008 to that in 2014?
Ensure brevity in your answer.  1.13. What is the ratio of the Rating (1=low 6=high) in Management rating in 2008 to that in 2014?
Give a very brief answer. 1.07. What is the ratio of the Rating (1=low 6=high) in Building human resources in 2009 to that in 2010?
Provide a succinct answer. 0.99. What is the ratio of the Rating (1=low 6=high) in Business regulatory environment in 2009 to that in 2010?
Offer a terse response. 1. What is the ratio of the Rating (1=low 6=high) in Debt policy in 2009 to that in 2010?
Your answer should be very brief. 1.02. What is the ratio of the Rating (1=low 6=high) in Management rating in 2009 to that in 2010?
Keep it short and to the point. 1.01. What is the ratio of the Rating (1=low 6=high) in Building human resources in 2009 to that in 2011?
Give a very brief answer. 0.98. What is the ratio of the Rating (1=low 6=high) in Business regulatory environment in 2009 to that in 2011?
Offer a terse response. 1.03. What is the ratio of the Rating (1=low 6=high) of Debt policy in 2009 to that in 2011?
Give a very brief answer. 1.08. What is the ratio of the Rating (1=low 6=high) in Management rating in 2009 to that in 2011?
Your answer should be compact. 1.04. What is the ratio of the Rating (1=low 6=high) of Building human resources in 2009 to that in 2012?
Your answer should be compact. 0.97. What is the ratio of the Rating (1=low 6=high) in Business regulatory environment in 2009 to that in 2012?
Provide a succinct answer. 1.05. What is the ratio of the Rating (1=low 6=high) of Debt policy in 2009 to that in 2012?
Ensure brevity in your answer.  1.14. What is the ratio of the Rating (1=low 6=high) in Management rating in 2009 to that in 2012?
Provide a short and direct response. 1.08. What is the ratio of the Rating (1=low 6=high) of Building human resources in 2009 to that in 2013?
Your response must be concise. 0.97. What is the ratio of the Rating (1=low 6=high) in Business regulatory environment in 2009 to that in 2013?
Offer a terse response. 1.05. What is the ratio of the Rating (1=low 6=high) in Debt policy in 2009 to that in 2013?
Ensure brevity in your answer.  1.13. What is the ratio of the Rating (1=low 6=high) in Management rating in 2009 to that in 2013?
Provide a short and direct response. 1.09. What is the ratio of the Rating (1=low 6=high) of Building human resources in 2009 to that in 2014?
Give a very brief answer. 0.96. What is the ratio of the Rating (1=low 6=high) of Business regulatory environment in 2009 to that in 2014?
Ensure brevity in your answer.  1.05. What is the ratio of the Rating (1=low 6=high) of Debt policy in 2009 to that in 2014?
Give a very brief answer. 1.16. What is the ratio of the Rating (1=low 6=high) in Management rating in 2009 to that in 2014?
Your answer should be compact. 1.1. What is the ratio of the Rating (1=low 6=high) of Building human resources in 2010 to that in 2011?
Offer a very short reply. 0.99. What is the ratio of the Rating (1=low 6=high) of Business regulatory environment in 2010 to that in 2011?
Make the answer very short. 1.03. What is the ratio of the Rating (1=low 6=high) of Debt policy in 2010 to that in 2011?
Provide a short and direct response. 1.05. What is the ratio of the Rating (1=low 6=high) of Management rating in 2010 to that in 2011?
Your answer should be compact. 1.03. What is the ratio of the Rating (1=low 6=high) of Building human resources in 2010 to that in 2012?
Your response must be concise. 0.99. What is the ratio of the Rating (1=low 6=high) of Business regulatory environment in 2010 to that in 2012?
Ensure brevity in your answer.  1.05. What is the ratio of the Rating (1=low 6=high) in Debt policy in 2010 to that in 2012?
Provide a succinct answer. 1.11. What is the ratio of the Rating (1=low 6=high) of Management rating in 2010 to that in 2012?
Ensure brevity in your answer.  1.07. What is the ratio of the Rating (1=low 6=high) of Building human resources in 2010 to that in 2013?
Provide a succinct answer. 0.98. What is the ratio of the Rating (1=low 6=high) in Business regulatory environment in 2010 to that in 2013?
Provide a short and direct response. 1.05. What is the ratio of the Rating (1=low 6=high) in Debt policy in 2010 to that in 2013?
Provide a succinct answer. 1.11. What is the ratio of the Rating (1=low 6=high) of Management rating in 2010 to that in 2013?
Provide a succinct answer. 1.08. What is the ratio of the Rating (1=low 6=high) of Building human resources in 2010 to that in 2014?
Provide a succinct answer. 0.97. What is the ratio of the Rating (1=low 6=high) of Business regulatory environment in 2010 to that in 2014?
Provide a succinct answer. 1.05. What is the ratio of the Rating (1=low 6=high) of Debt policy in 2010 to that in 2014?
Give a very brief answer. 1.13. What is the ratio of the Rating (1=low 6=high) of Management rating in 2010 to that in 2014?
Provide a succinct answer. 1.09. What is the ratio of the Rating (1=low 6=high) of Business regulatory environment in 2011 to that in 2012?
Your answer should be compact. 1.02. What is the ratio of the Rating (1=low 6=high) in Debt policy in 2011 to that in 2012?
Your answer should be compact. 1.05. What is the ratio of the Rating (1=low 6=high) of Management rating in 2011 to that in 2012?
Your answer should be compact. 1.04. What is the ratio of the Rating (1=low 6=high) of Building human resources in 2011 to that in 2013?
Provide a short and direct response. 0.99. What is the ratio of the Rating (1=low 6=high) of Business regulatory environment in 2011 to that in 2013?
Make the answer very short. 1.02. What is the ratio of the Rating (1=low 6=high) in Debt policy in 2011 to that in 2013?
Give a very brief answer. 1.05. What is the ratio of the Rating (1=low 6=high) in Management rating in 2011 to that in 2013?
Provide a succinct answer. 1.05. What is the ratio of the Rating (1=low 6=high) in Building human resources in 2011 to that in 2014?
Offer a terse response. 0.98. What is the ratio of the Rating (1=low 6=high) of Business regulatory environment in 2011 to that in 2014?
Offer a very short reply. 1.02. What is the ratio of the Rating (1=low 6=high) in Debt policy in 2011 to that in 2014?
Offer a very short reply. 1.07. What is the ratio of the Rating (1=low 6=high) of Management rating in 2011 to that in 2014?
Provide a short and direct response. 1.06. What is the ratio of the Rating (1=low 6=high) in Business regulatory environment in 2012 to that in 2013?
Your response must be concise. 1. What is the ratio of the Rating (1=low 6=high) of Management rating in 2012 to that in 2013?
Keep it short and to the point. 1.01. What is the ratio of the Rating (1=low 6=high) of Building human resources in 2012 to that in 2014?
Offer a very short reply. 0.99. What is the ratio of the Rating (1=low 6=high) in Debt policy in 2012 to that in 2014?
Your response must be concise. 1.02. What is the ratio of the Rating (1=low 6=high) of Management rating in 2012 to that in 2014?
Provide a succinct answer. 1.02. What is the ratio of the Rating (1=low 6=high) of Business regulatory environment in 2013 to that in 2014?
Your answer should be very brief. 1. What is the ratio of the Rating (1=low 6=high) in Debt policy in 2013 to that in 2014?
Your response must be concise. 1.02. What is the difference between the highest and the second highest Rating (1=low 6=high) of Building human resources?
Ensure brevity in your answer.  0.03. What is the difference between the highest and the second highest Rating (1=low 6=high) in Debt policy?
Make the answer very short. 0.09. What is the difference between the highest and the second highest Rating (1=low 6=high) of Management rating?
Make the answer very short. 0.03. What is the difference between the highest and the lowest Rating (1=low 6=high) in Building human resources?
Provide a short and direct response. 0.14. What is the difference between the highest and the lowest Rating (1=low 6=high) of Business regulatory environment?
Provide a short and direct response. 0.15. What is the difference between the highest and the lowest Rating (1=low 6=high) in Debt policy?
Make the answer very short. 0.52. What is the difference between the highest and the lowest Rating (1=low 6=high) in Management rating?
Offer a very short reply. 0.34. 